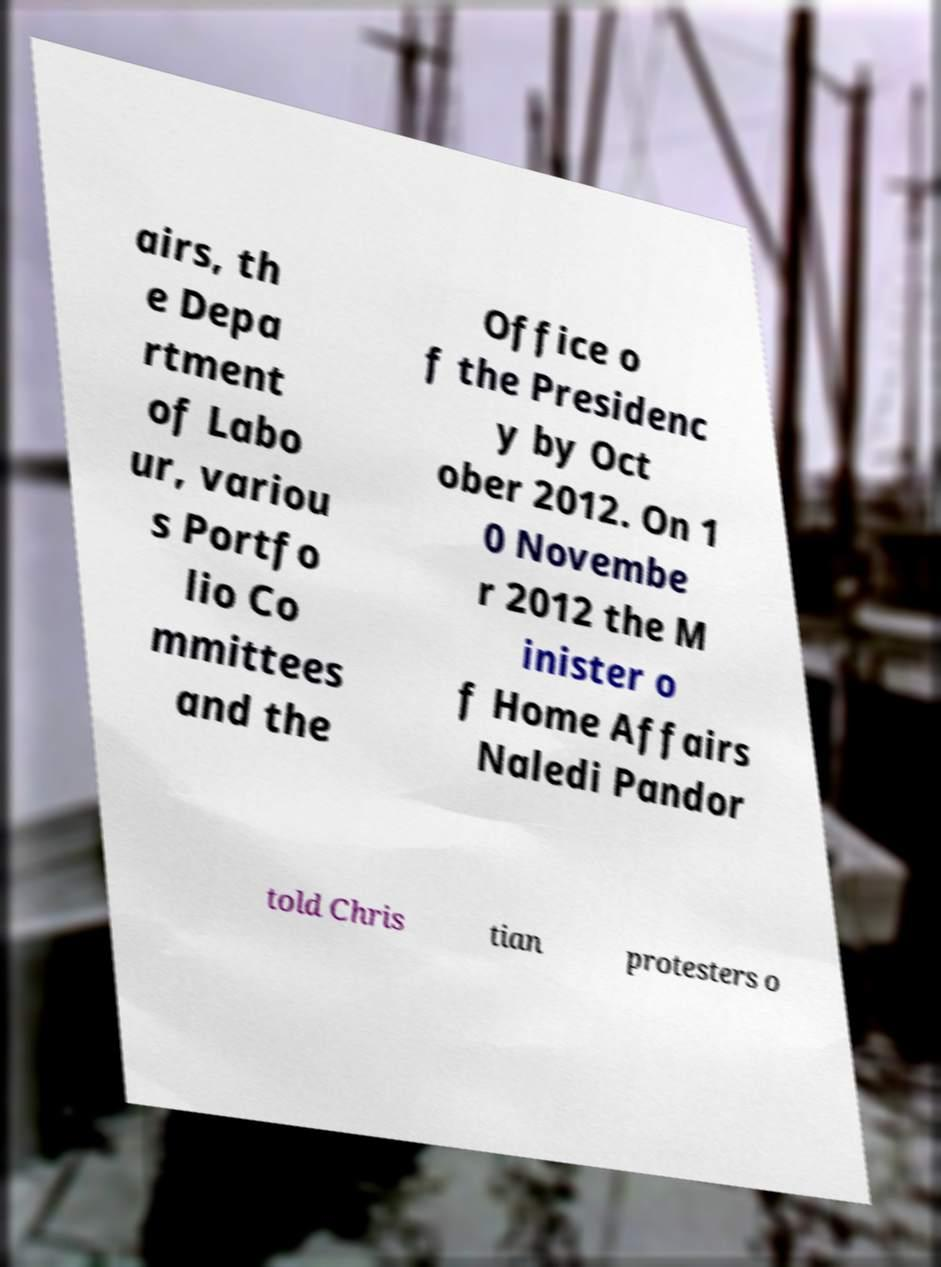There's text embedded in this image that I need extracted. Can you transcribe it verbatim? airs, th e Depa rtment of Labo ur, variou s Portfo lio Co mmittees and the Office o f the Presidenc y by Oct ober 2012. On 1 0 Novembe r 2012 the M inister o f Home Affairs Naledi Pandor told Chris tian protesters o 